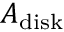<formula> <loc_0><loc_0><loc_500><loc_500>A _ { d i s k }</formula> 